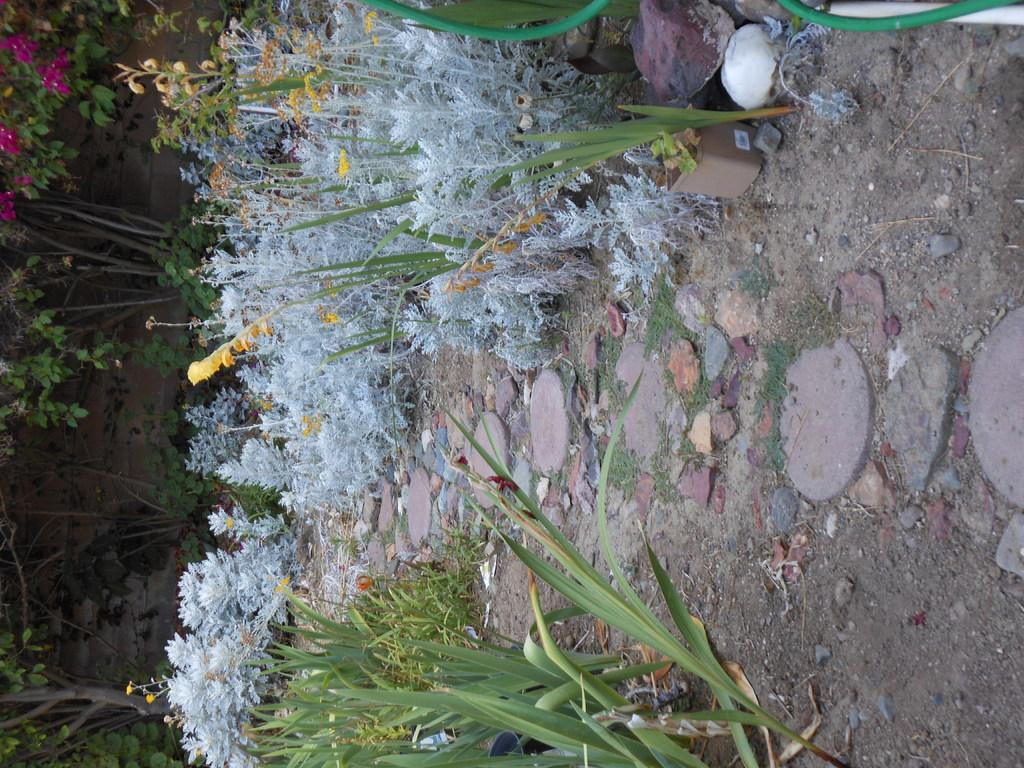What type of vegetation is present on the ground in the image? There are plants on the ground in the image. What can be seen in the background of the image? There are trees at the back in the image. Do the plants have any distinguishing features? Yes, the plants have flowers on them. How many times do the plants exchange their positions in the image? The plants do not exchange their positions in the image; they remain stationary. Can you describe the step-by-step process of the plants turning in the image? The plants do not turn in the image; they are stationary and do not exhibit any movement. 